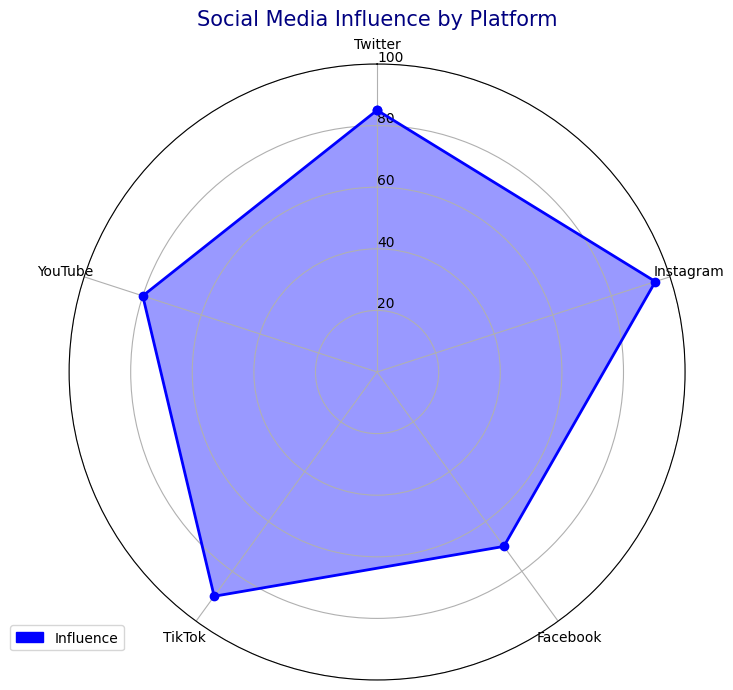What's the most influential social media platform according to the chart? To find the most influential platform, look for the platform with the highest value on the chart. Instagram has the highest influence value at 95.
Answer: Instagram Which platform has the lowest influence score? Identify the platform with the smallest value on the radar chart. Facebook has the lowest influence score at 70.
Answer: Facebook Compare the influence of TikTok and YouTube. Which one is higher and by how much? TikTok's influence is 90 and YouTube's is 80. Subtract YouTube's influence from TikTok's influence to find the difference (90 - 80 = 10).
Answer: TikTok is higher by 10 What's the combined influence score of Twitter and Facebook? Add the influence scores of Twitter and Facebook (85 + 70 = 155).
Answer: 155 What's the difference in influence between the highest and lowest ranked platforms? Subtract the influence score of the platform with the lowest influence (Facebook, 70) from the platform with the highest influence (Instagram, 95) (95 - 70 = 25).
Answer: 25 Which platforms have an influence score greater than 80? Identify all platforms with influence scores above 80. Twitter (85), Instagram (95), TikTok (90), and YouTube (80) are above 80. However, YouTube does not qualify as it is exactly 80.
Answer: Twitter, Instagram, TikTok What is the average influence score across all platforms? Add all the influence scores together and divide by the number of platforms (85 + 95 + 70 + 90 + 80 = 420; 420 / 5 = 84).
Answer: 84 Among Twitter, YouTube, and TikTok, which platform has the median influence score? Order the influence scores of Twitter (85), YouTube (80), and TikTok (90). The median value is the middle one (80, 85, 90).
Answer: Twitter Is the influence of Facebook closer to Twitter or YouTube? Compare the absolute difference between Facebook's influence and Twitter's influence (85 - 70 = 15) and the difference between Facebook's influence and YouTube's influence (80 - 70 = 10).
Answer: YouTube How many platforms have influence scores less than the average influence score? First, find the average influence score (84). Identify platforms with scores below 84: Facebook (70) and YouTube (80).
Answer: 2 